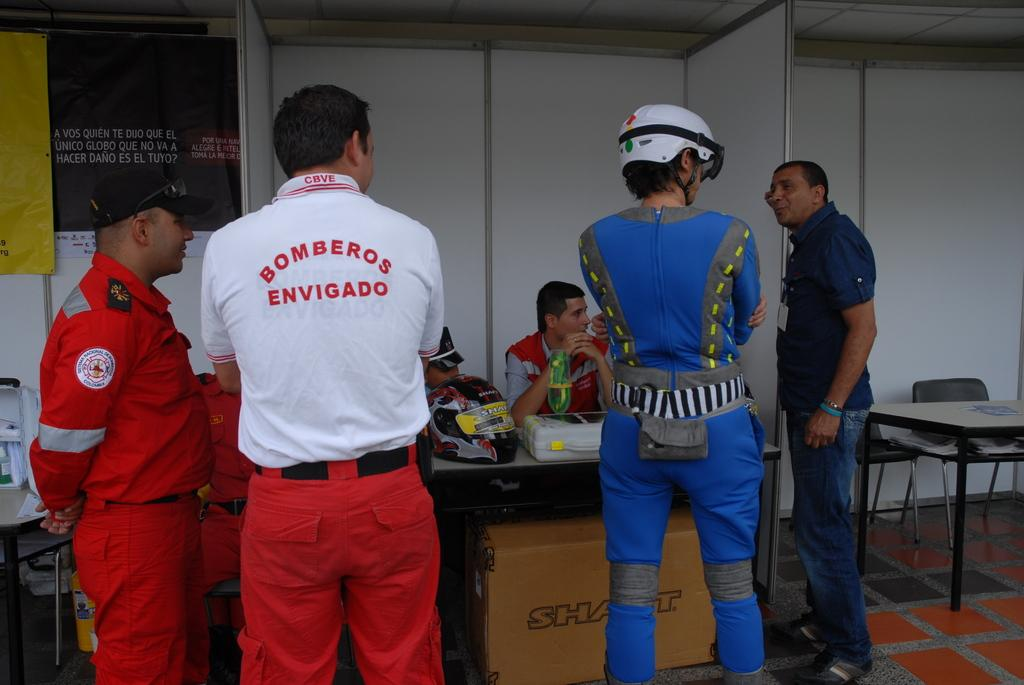<image>
Share a concise interpretation of the image provided. People standing conversing with a white shirt that has red lettering Bomberos Envigado. 